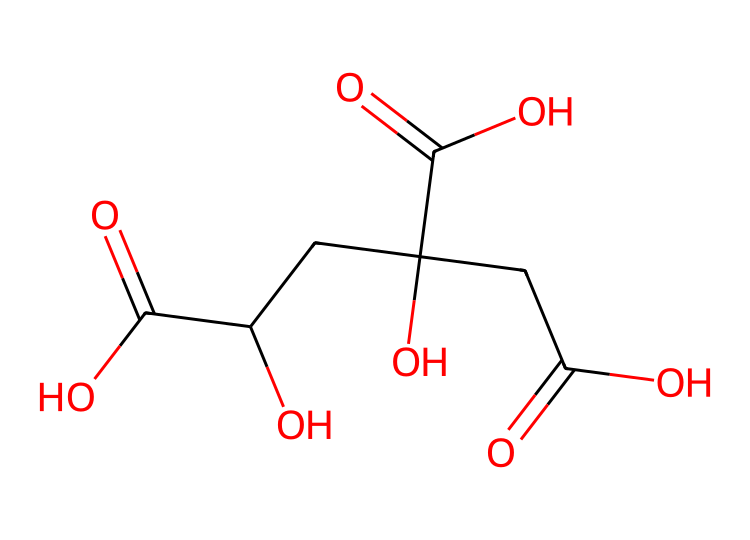What is the chemical name of the compound represented in the SMILES? The SMILES representation identifies the structure as citric acid, which is a well-known organic acid commonly found in citrus fruits.
Answer: citric acid How many carboxylic acid groups are present in this chemical? By analyzing the structure, we can see there are three distinct carboxylic acid groups present, indicated by the three (-COOH) functional groups.
Answer: three What functional groups can you identify in this structure? The structure contains hydroxyl (-OH) groups and carboxylic acid (-COOH) groups. These functional groups are identified by examining the elements and bonds present in the molecule.
Answer: hydroxyl and carboxylic acid What is the pH range generally associated with citric acid? Citric acid is considered a weak acid with a general pH range of around 2 to 3 in solution, indicating its acidity level.
Answer: 2 to 3 How does citric acid affect the flavor profile of baked goods? Citric acid enhances flavors by providing a tartness that can balance sweetness in baked goods, improving overall taste harmony.
Answer: balance sweetness 